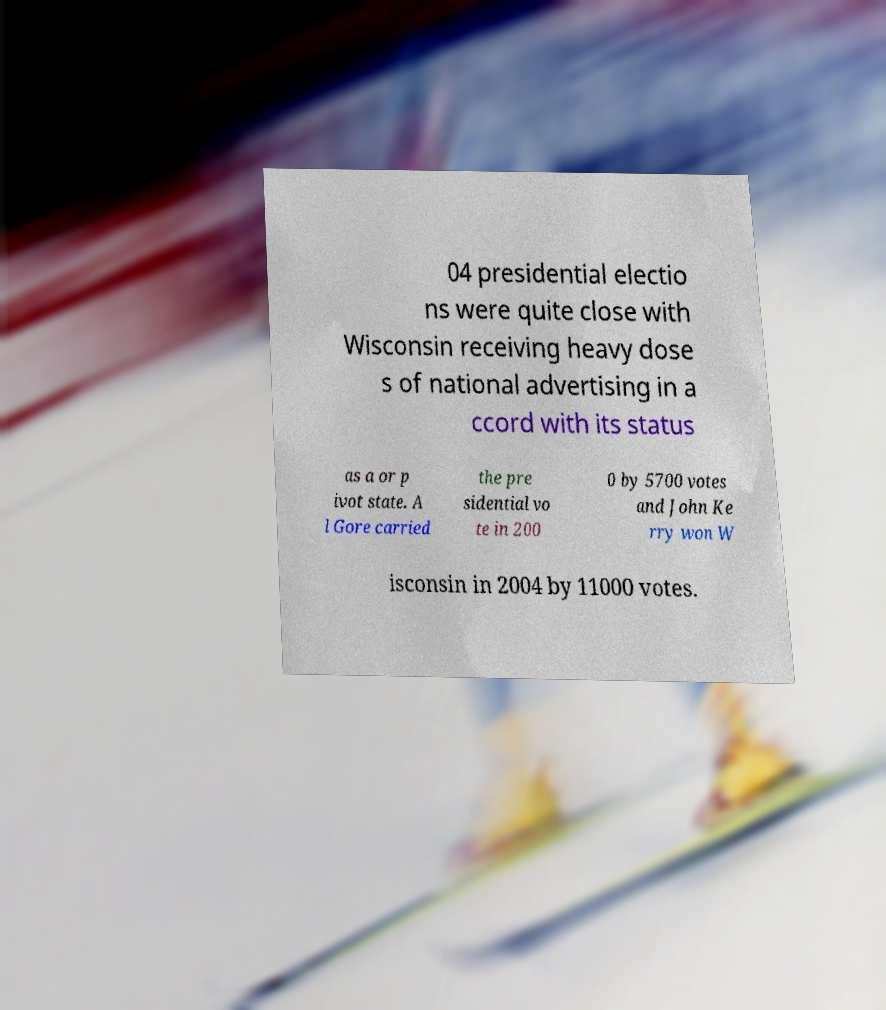Could you assist in decoding the text presented in this image and type it out clearly? 04 presidential electio ns were quite close with Wisconsin receiving heavy dose s of national advertising in a ccord with its status as a or p ivot state. A l Gore carried the pre sidential vo te in 200 0 by 5700 votes and John Ke rry won W isconsin in 2004 by 11000 votes. 